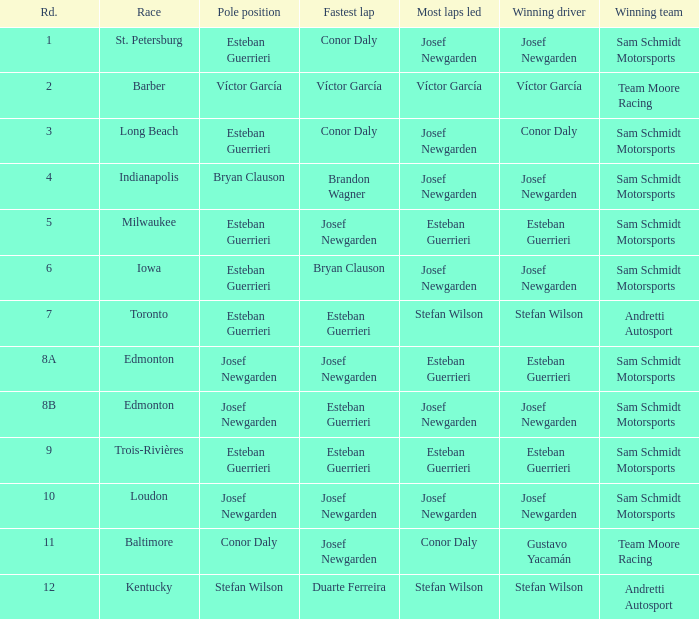What race did josef newgarden have the fastest lap and lead the most laps? Loudon. 